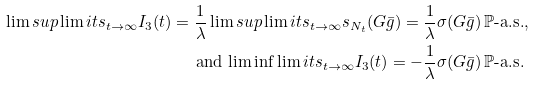<formula> <loc_0><loc_0><loc_500><loc_500>\lim s u p \lim i t s _ { t \to \infty } I _ { 3 } ( t ) = \frac { 1 } { \lambda } \lim s u p \lim i t s _ { t \to \infty } s _ { N _ { t } } ( G \bar { g } ) = \frac { 1 } { \lambda } \sigma ( G \bar { g } ) \, & \mathbb { P } \text {-a.s.} , \\ \text {and} \, \liminf \lim i t s _ { t \to \infty } I _ { 3 } ( t ) = - \frac { 1 } { \lambda } \sigma ( G \bar { g } ) \, & \mathbb { P } \text {-a.s.}</formula> 